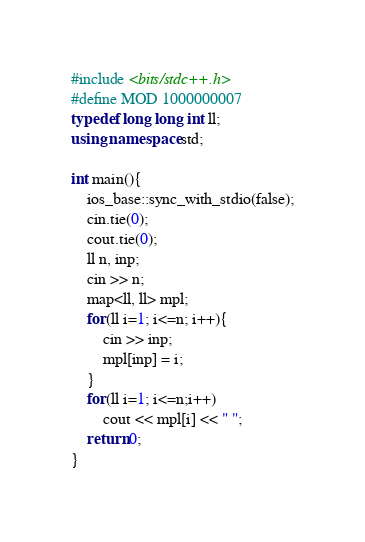Convert code to text. <code><loc_0><loc_0><loc_500><loc_500><_C++_>#include <bits/stdc++.h>
#define MOD 1000000007
typedef long long int ll;
using namespace std;

int main(){
    ios_base::sync_with_stdio(false);
    cin.tie(0);
    cout.tie(0);
    ll n, inp;
    cin >> n;
    map<ll, ll> mpl;
    for(ll i=1; i<=n; i++){
        cin >> inp;
        mpl[inp] = i;
    }
    for(ll i=1; i<=n;i++)
        cout << mpl[i] << " ";
    return 0;
}</code> 